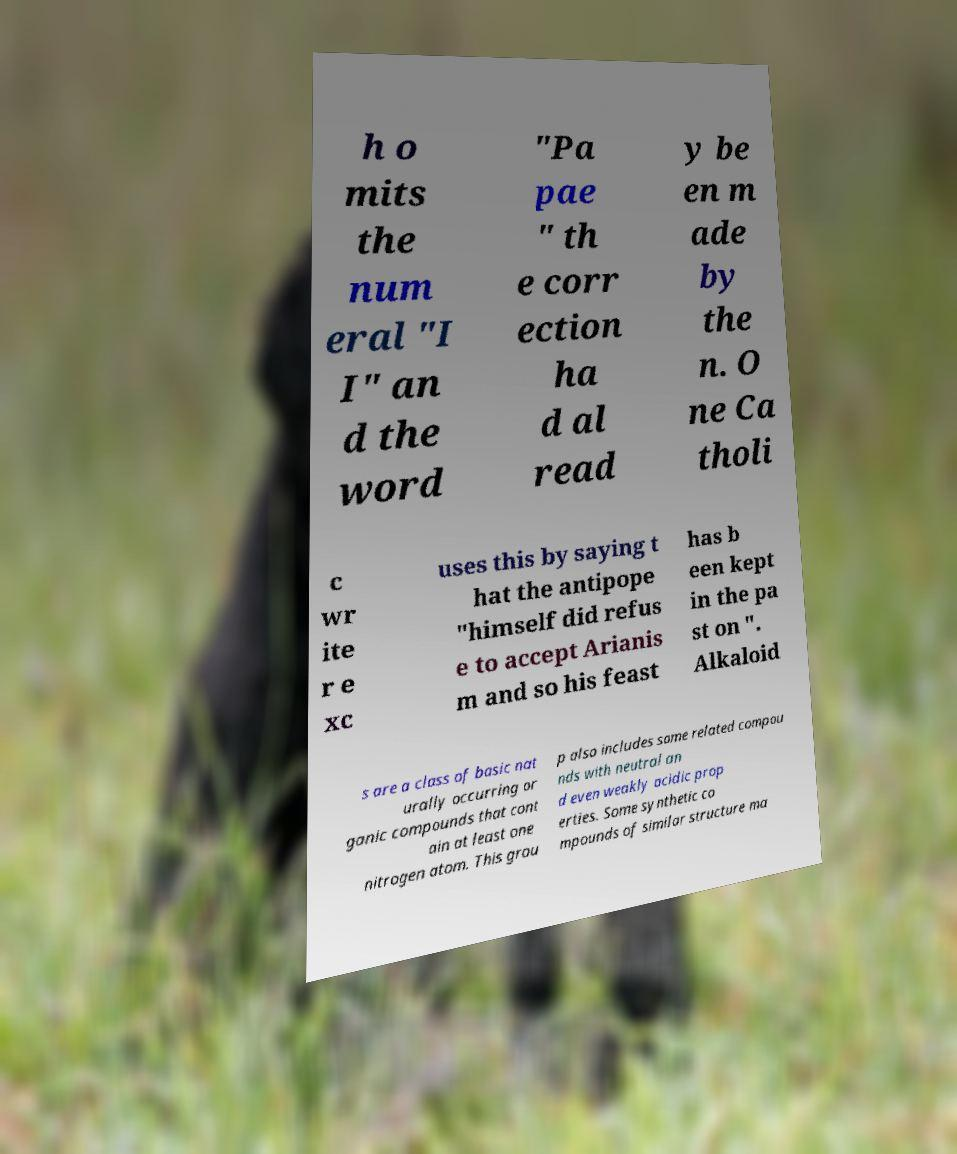I need the written content from this picture converted into text. Can you do that? h o mits the num eral "I I" an d the word "Pa pae " th e corr ection ha d al read y be en m ade by the n. O ne Ca tholi c wr ite r e xc uses this by saying t hat the antipope "himself did refus e to accept Arianis m and so his feast has b een kept in the pa st on ". Alkaloid s are a class of basic nat urally occurring or ganic compounds that cont ain at least one nitrogen atom. This grou p also includes some related compou nds with neutral an d even weakly acidic prop erties. Some synthetic co mpounds of similar structure ma 